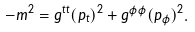<formula> <loc_0><loc_0><loc_500><loc_500>- m ^ { 2 } = g ^ { t t } ( p _ { t } ) ^ { 2 } + g ^ { \phi \phi } ( p _ { \phi } ) ^ { 2 } .</formula> 